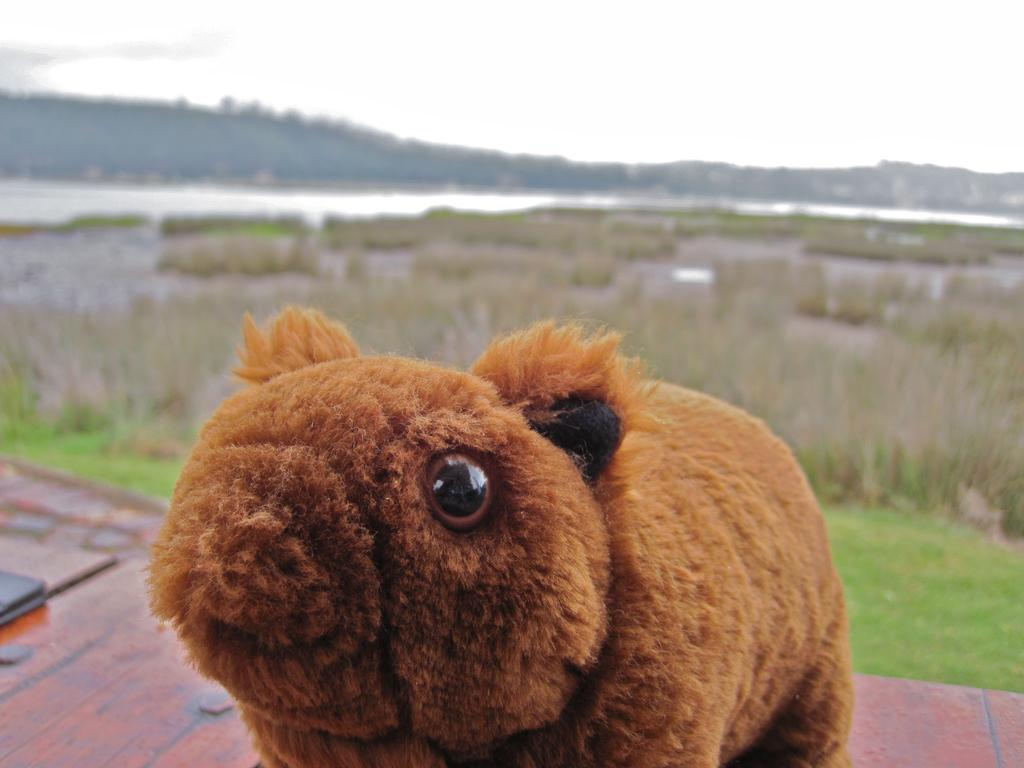What is the main subject in the foreground of the picture? There is a teddy bear in the foreground of the picture. Where is the teddy bear located? The teddy bear is on a wooden table. What can be seen in the background of the image? There is a farm field and hills visible in the background of the image. What type of oranges are being harvested in the background of the image? There are no oranges or any produce visible in the image; it features a farm field and hills in the background. 